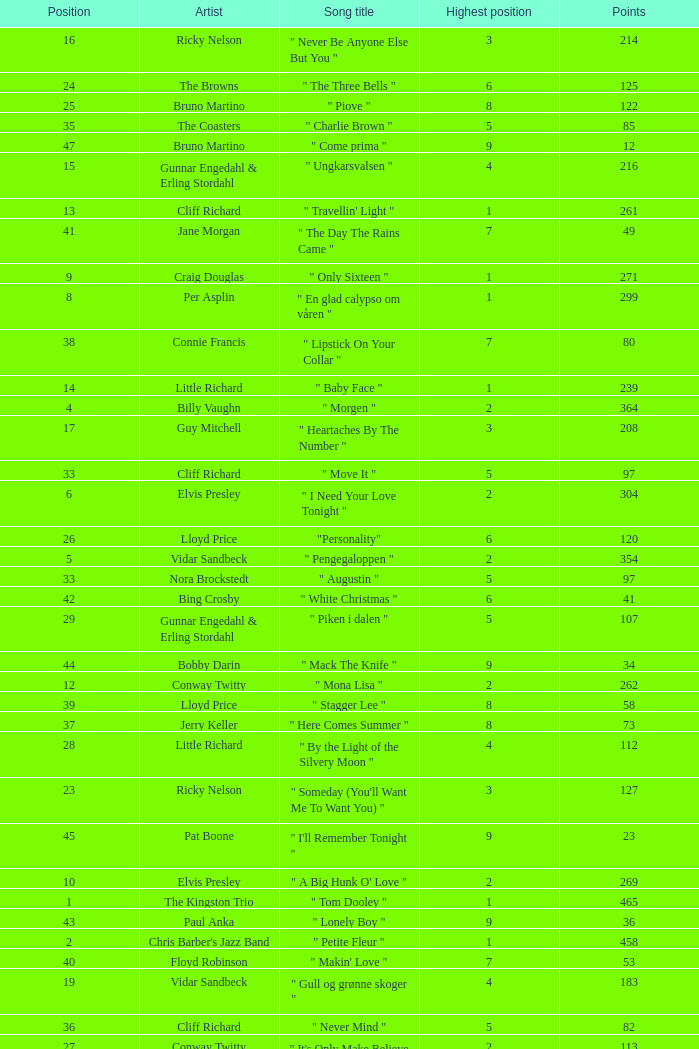What is the nme of the song performed by billy vaughn? " Morgen ". 